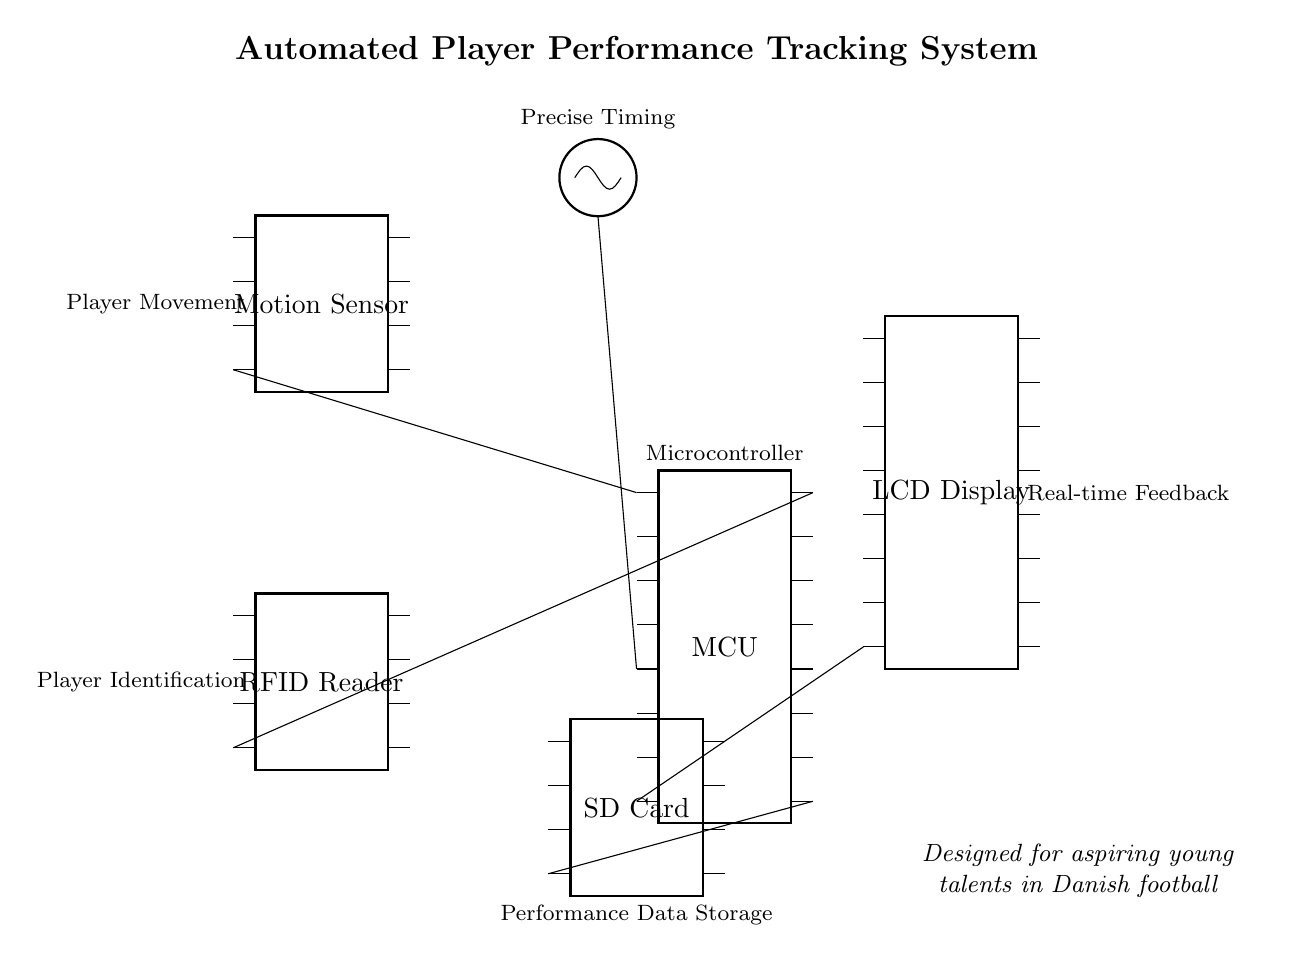What is the main component in the circuit? The main component is the microcontroller, which is indicated by the label "MCU" in the diagram. This component is essential for processing data from the sensors.
Answer: microcontroller What type of sensor is used for player movement? The circuit diagram shows a motion sensor labeled accordingly, which captures the player's movements during training sessions.
Answer: motion sensor How many pins does the LCD display have? The LCD display is represented in the diagram with a total of sixteen pins, allowing for various connections to the microcontroller.
Answer: sixteen Which component is responsible for precise timing? The clock component in the diagram is labeled as "Clock" and is explicitly marked as providing precise timing for the microcontroller operation.
Answer: Clock What device is used for storing performance data? The circuit includes an SD card labeled as "SD Card," which is responsible for storing the performance data collected during training.
Answer: SD Card How does the motion sensor connect to the microcontroller? The motion sensor connects to the microcontroller through a specific pin indicated in the diagram, which shows a direct line between the two components.
Answer: pin 4 What indicates real-time feedback in the system? The LCD display is labeled as providing real-time feedback, suggesting it processes and shows the data collected during the training sessions.
Answer: LCD Display 